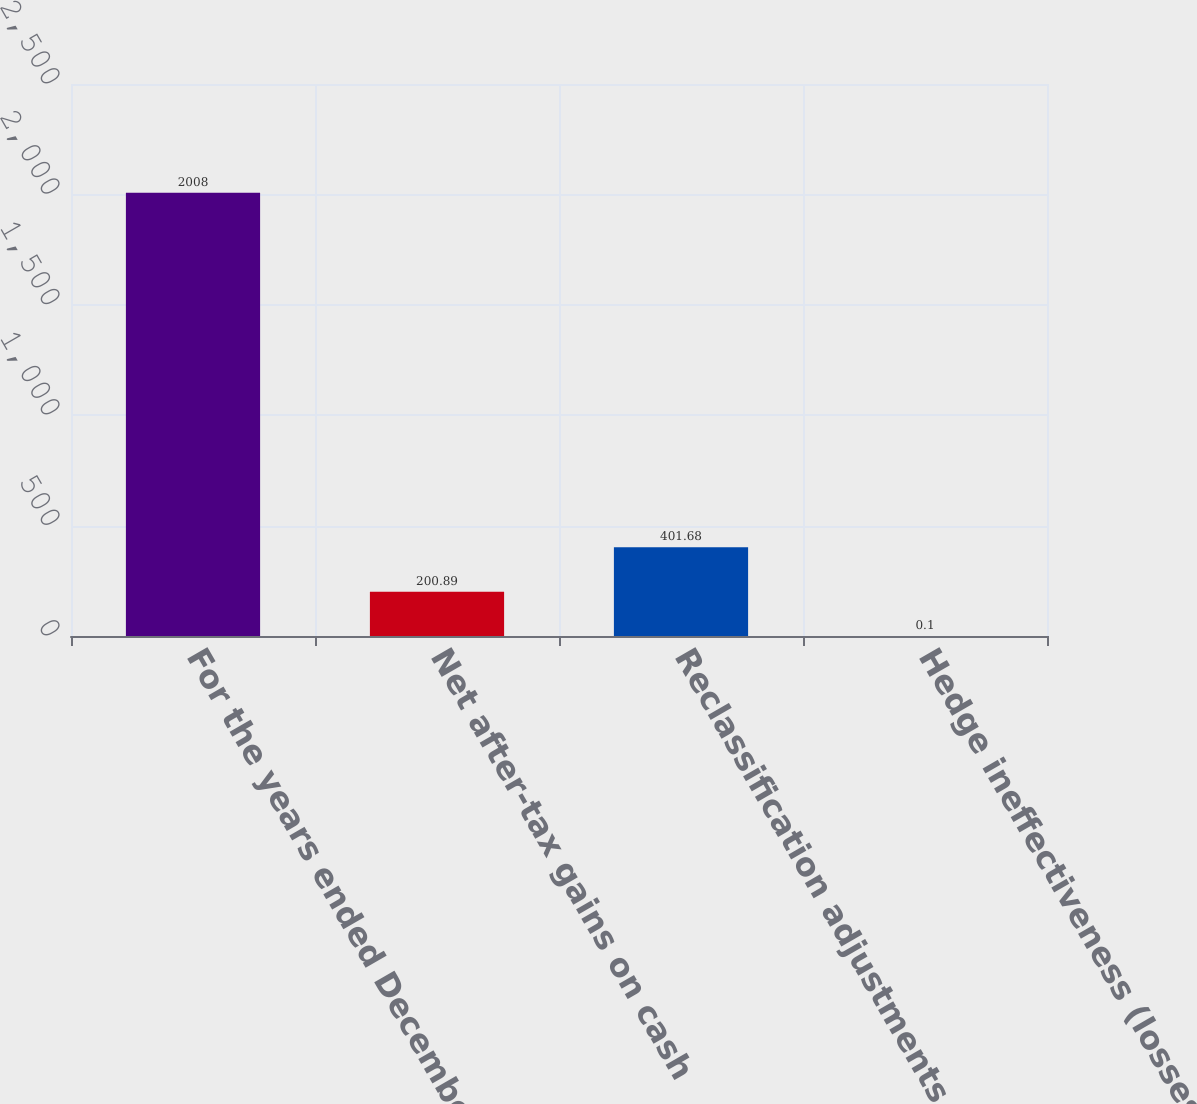Convert chart. <chart><loc_0><loc_0><loc_500><loc_500><bar_chart><fcel>For the years ended December<fcel>Net after-tax gains on cash<fcel>Reclassification adjustments<fcel>Hedge ineffectiveness (losses)<nl><fcel>2008<fcel>200.89<fcel>401.68<fcel>0.1<nl></chart> 